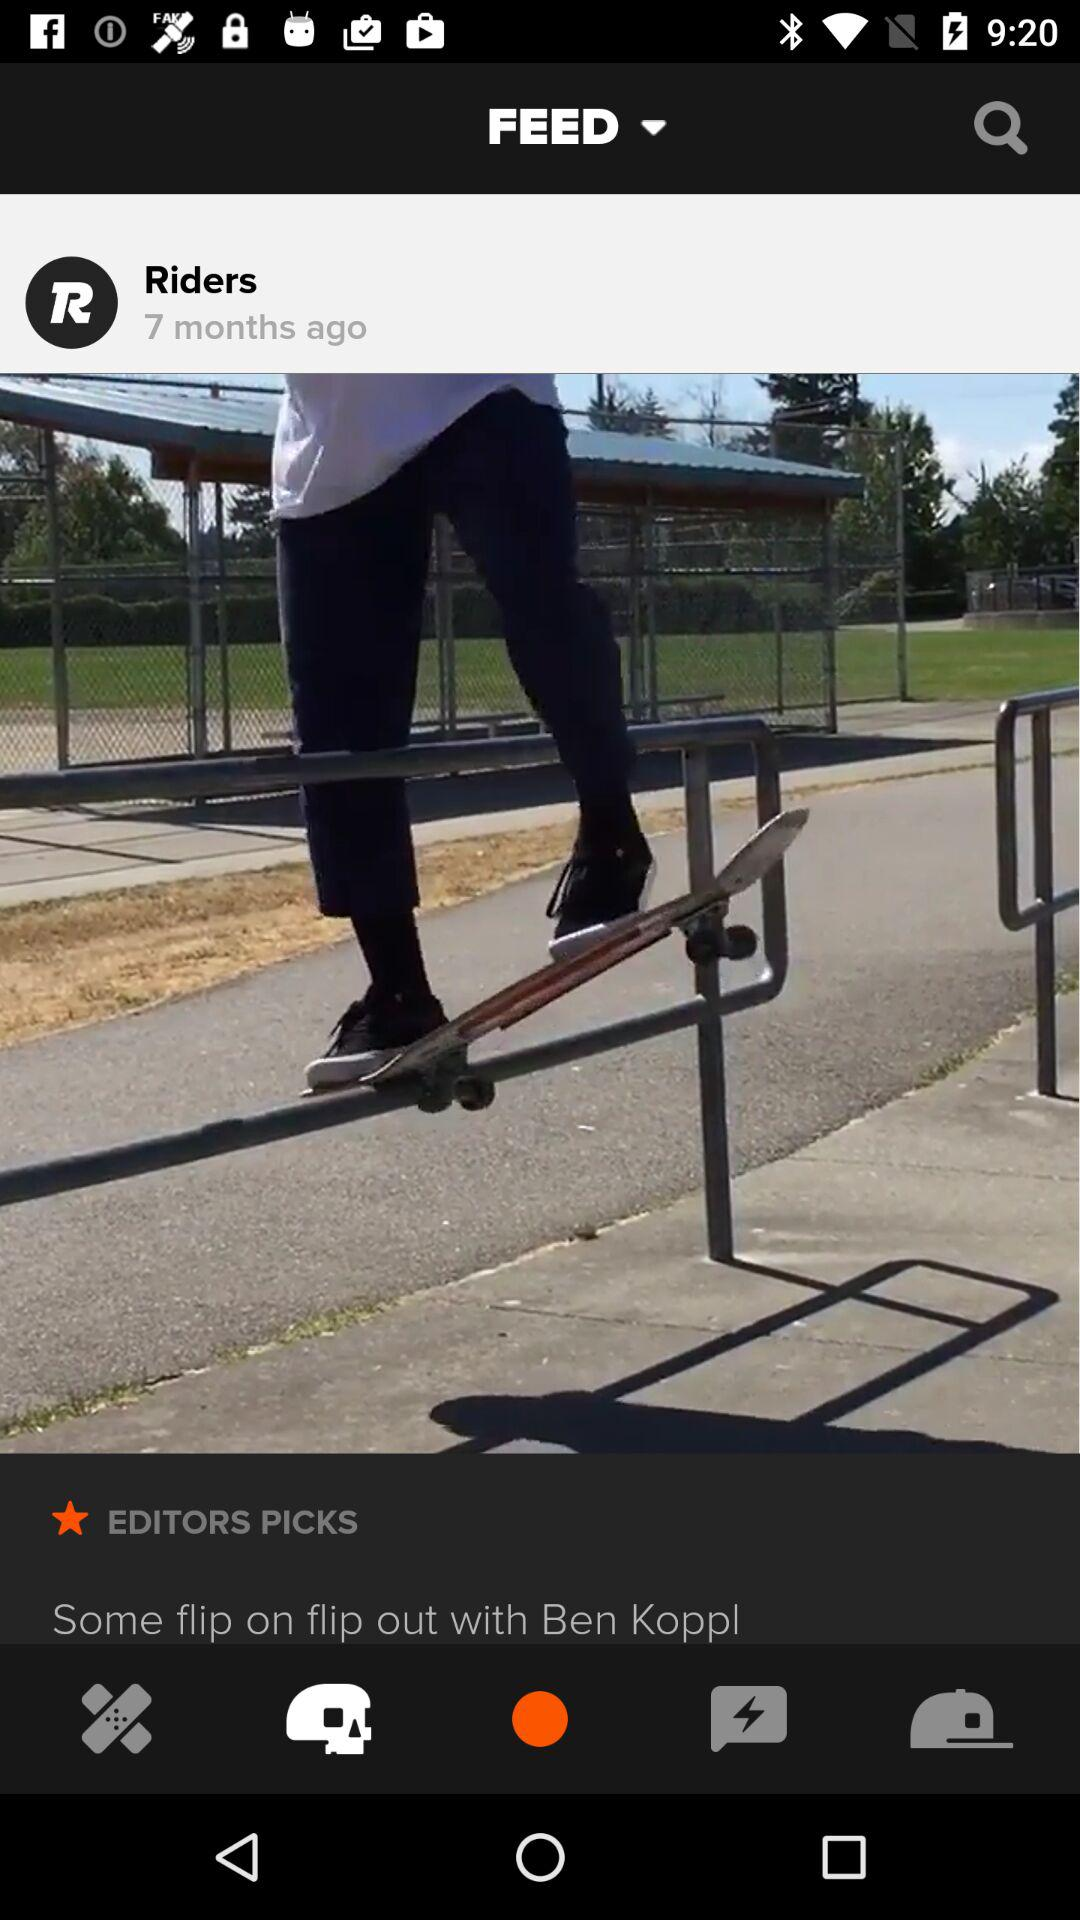What is the profile name?
When the provided information is insufficient, respond with <no answer>. <no answer> 